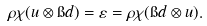<formula> <loc_0><loc_0><loc_500><loc_500>\rho \chi ( u \otimes \i d ) = \varepsilon = \rho \chi ( \i d \otimes u ) .</formula> 